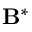<formula> <loc_0><loc_0><loc_500><loc_500>B ^ { * }</formula> 